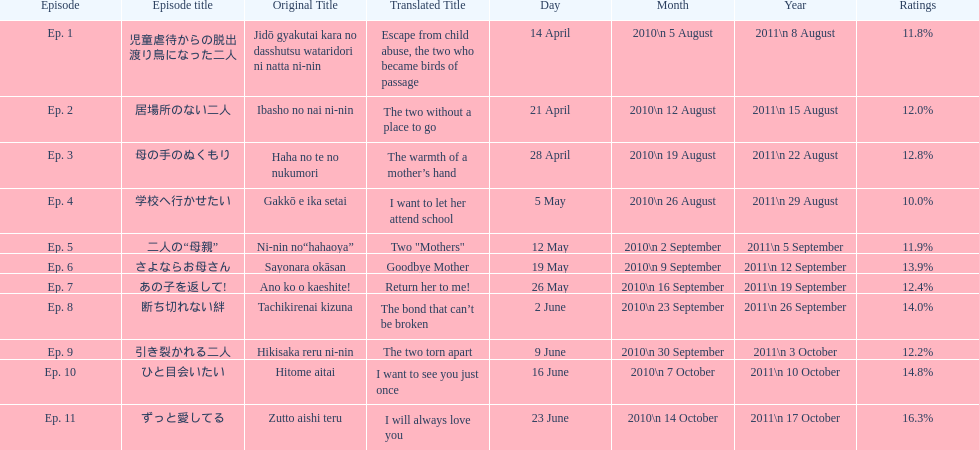What was the name of the next episode after goodbye mother? あの子を返して!. 